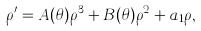<formula> <loc_0><loc_0><loc_500><loc_500>\rho ^ { \prime } = A ( \theta ) \rho ^ { 3 } + B ( \theta ) \rho ^ { 2 } + a _ { 1 } \rho ,</formula> 